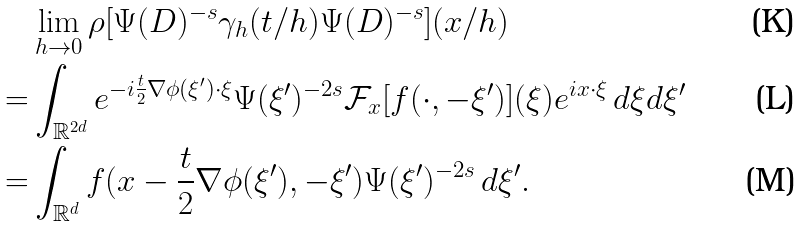Convert formula to latex. <formula><loc_0><loc_0><loc_500><loc_500>& \lim _ { h \to 0 } \rho [ \Psi ( D ) ^ { - s } \gamma _ { h } ( t / h ) \Psi ( D ) ^ { - s } ] ( x / h ) \\ = & \int _ { \mathbb { R } ^ { 2 d } } e ^ { - i \frac { t } { 2 } \nabla \phi ( \xi ^ { \prime } ) \cdot \xi } \Psi ( \xi ^ { \prime } ) ^ { - 2 s } \mathcal { F } _ { x } [ f ( \cdot , - \xi ^ { \prime } ) ] ( \xi ) e ^ { i x \cdot \xi } \, d \xi d \xi ^ { \prime } \\ = & \int _ { \mathbb { R } ^ { d } } f ( x - \frac { t } { 2 } \nabla \phi ( \xi ^ { \prime } ) , - \xi ^ { \prime } ) \Psi ( \xi ^ { \prime } ) ^ { - 2 s } \, d \xi ^ { \prime } .</formula> 